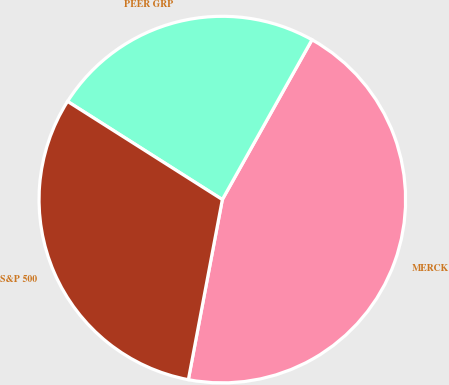<chart> <loc_0><loc_0><loc_500><loc_500><pie_chart><fcel>MERCK<fcel>PEER GRP<fcel>S&P 500<nl><fcel>44.83%<fcel>24.14%<fcel>31.03%<nl></chart> 